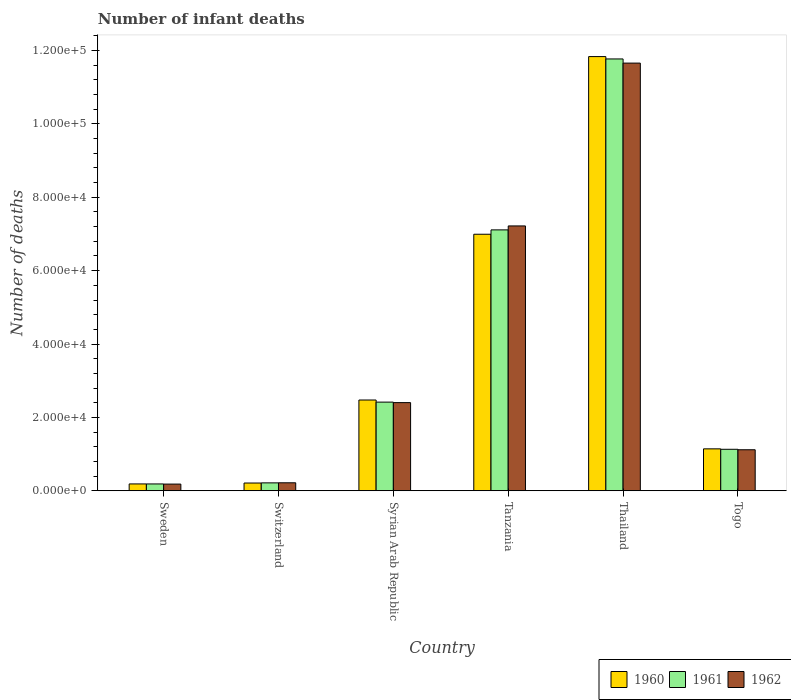Are the number of bars per tick equal to the number of legend labels?
Provide a succinct answer. Yes. Are the number of bars on each tick of the X-axis equal?
Keep it short and to the point. Yes. What is the label of the 4th group of bars from the left?
Make the answer very short. Tanzania. In how many cases, is the number of bars for a given country not equal to the number of legend labels?
Give a very brief answer. 0. What is the number of infant deaths in 1960 in Switzerland?
Offer a very short reply. 2116. Across all countries, what is the maximum number of infant deaths in 1962?
Make the answer very short. 1.17e+05. Across all countries, what is the minimum number of infant deaths in 1962?
Offer a terse response. 1827. In which country was the number of infant deaths in 1960 maximum?
Offer a terse response. Thailand. What is the total number of infant deaths in 1960 in the graph?
Offer a very short reply. 2.28e+05. What is the difference between the number of infant deaths in 1961 in Sweden and that in Tanzania?
Make the answer very short. -6.92e+04. What is the difference between the number of infant deaths in 1962 in Thailand and the number of infant deaths in 1960 in Tanzania?
Offer a terse response. 4.66e+04. What is the average number of infant deaths in 1962 per country?
Your answer should be compact. 3.80e+04. What is the difference between the number of infant deaths of/in 1962 and number of infant deaths of/in 1961 in Switzerland?
Your answer should be very brief. 22. What is the ratio of the number of infant deaths in 1962 in Sweden to that in Togo?
Provide a short and direct response. 0.16. Is the number of infant deaths in 1960 in Switzerland less than that in Thailand?
Provide a succinct answer. Yes. What is the difference between the highest and the second highest number of infant deaths in 1961?
Make the answer very short. -4.66e+04. What is the difference between the highest and the lowest number of infant deaths in 1960?
Provide a succinct answer. 1.16e+05. In how many countries, is the number of infant deaths in 1960 greater than the average number of infant deaths in 1960 taken over all countries?
Offer a very short reply. 2. Is the sum of the number of infant deaths in 1962 in Tanzania and Togo greater than the maximum number of infant deaths in 1960 across all countries?
Make the answer very short. No. Are all the bars in the graph horizontal?
Keep it short and to the point. No. What is the difference between two consecutive major ticks on the Y-axis?
Make the answer very short. 2.00e+04. Does the graph contain grids?
Offer a terse response. No. Where does the legend appear in the graph?
Your answer should be compact. Bottom right. What is the title of the graph?
Provide a succinct answer. Number of infant deaths. Does "1996" appear as one of the legend labels in the graph?
Offer a very short reply. No. What is the label or title of the X-axis?
Your answer should be compact. Country. What is the label or title of the Y-axis?
Ensure brevity in your answer.  Number of deaths. What is the Number of deaths in 1960 in Sweden?
Offer a terse response. 1868. What is the Number of deaths in 1961 in Sweden?
Give a very brief answer. 1865. What is the Number of deaths of 1962 in Sweden?
Offer a very short reply. 1827. What is the Number of deaths of 1960 in Switzerland?
Give a very brief answer. 2116. What is the Number of deaths in 1961 in Switzerland?
Your answer should be compact. 2157. What is the Number of deaths of 1962 in Switzerland?
Your answer should be very brief. 2179. What is the Number of deaths in 1960 in Syrian Arab Republic?
Make the answer very short. 2.47e+04. What is the Number of deaths of 1961 in Syrian Arab Republic?
Keep it short and to the point. 2.42e+04. What is the Number of deaths in 1962 in Syrian Arab Republic?
Make the answer very short. 2.40e+04. What is the Number of deaths of 1960 in Tanzania?
Your answer should be compact. 6.99e+04. What is the Number of deaths in 1961 in Tanzania?
Offer a terse response. 7.11e+04. What is the Number of deaths of 1962 in Tanzania?
Make the answer very short. 7.22e+04. What is the Number of deaths of 1960 in Thailand?
Provide a succinct answer. 1.18e+05. What is the Number of deaths of 1961 in Thailand?
Offer a very short reply. 1.18e+05. What is the Number of deaths in 1962 in Thailand?
Your response must be concise. 1.17e+05. What is the Number of deaths of 1960 in Togo?
Offer a very short reply. 1.14e+04. What is the Number of deaths of 1961 in Togo?
Provide a short and direct response. 1.13e+04. What is the Number of deaths in 1962 in Togo?
Provide a succinct answer. 1.12e+04. Across all countries, what is the maximum Number of deaths in 1960?
Your answer should be compact. 1.18e+05. Across all countries, what is the maximum Number of deaths of 1961?
Your answer should be compact. 1.18e+05. Across all countries, what is the maximum Number of deaths of 1962?
Your response must be concise. 1.17e+05. Across all countries, what is the minimum Number of deaths in 1960?
Keep it short and to the point. 1868. Across all countries, what is the minimum Number of deaths in 1961?
Provide a short and direct response. 1865. Across all countries, what is the minimum Number of deaths of 1962?
Offer a terse response. 1827. What is the total Number of deaths of 1960 in the graph?
Make the answer very short. 2.28e+05. What is the total Number of deaths of 1961 in the graph?
Keep it short and to the point. 2.28e+05. What is the total Number of deaths of 1962 in the graph?
Offer a terse response. 2.28e+05. What is the difference between the Number of deaths in 1960 in Sweden and that in Switzerland?
Give a very brief answer. -248. What is the difference between the Number of deaths in 1961 in Sweden and that in Switzerland?
Provide a succinct answer. -292. What is the difference between the Number of deaths in 1962 in Sweden and that in Switzerland?
Offer a very short reply. -352. What is the difference between the Number of deaths of 1960 in Sweden and that in Syrian Arab Republic?
Provide a short and direct response. -2.29e+04. What is the difference between the Number of deaths of 1961 in Sweden and that in Syrian Arab Republic?
Your response must be concise. -2.23e+04. What is the difference between the Number of deaths of 1962 in Sweden and that in Syrian Arab Republic?
Provide a succinct answer. -2.22e+04. What is the difference between the Number of deaths of 1960 in Sweden and that in Tanzania?
Your response must be concise. -6.81e+04. What is the difference between the Number of deaths in 1961 in Sweden and that in Tanzania?
Offer a very short reply. -6.92e+04. What is the difference between the Number of deaths of 1962 in Sweden and that in Tanzania?
Your answer should be very brief. -7.04e+04. What is the difference between the Number of deaths of 1960 in Sweden and that in Thailand?
Offer a very short reply. -1.16e+05. What is the difference between the Number of deaths in 1961 in Sweden and that in Thailand?
Provide a short and direct response. -1.16e+05. What is the difference between the Number of deaths of 1962 in Sweden and that in Thailand?
Give a very brief answer. -1.15e+05. What is the difference between the Number of deaths in 1960 in Sweden and that in Togo?
Ensure brevity in your answer.  -9563. What is the difference between the Number of deaths of 1961 in Sweden and that in Togo?
Your answer should be very brief. -9446. What is the difference between the Number of deaths in 1962 in Sweden and that in Togo?
Your response must be concise. -9358. What is the difference between the Number of deaths of 1960 in Switzerland and that in Syrian Arab Republic?
Provide a short and direct response. -2.26e+04. What is the difference between the Number of deaths of 1961 in Switzerland and that in Syrian Arab Republic?
Provide a short and direct response. -2.20e+04. What is the difference between the Number of deaths of 1962 in Switzerland and that in Syrian Arab Republic?
Ensure brevity in your answer.  -2.19e+04. What is the difference between the Number of deaths of 1960 in Switzerland and that in Tanzania?
Make the answer very short. -6.78e+04. What is the difference between the Number of deaths of 1961 in Switzerland and that in Tanzania?
Offer a very short reply. -6.90e+04. What is the difference between the Number of deaths of 1962 in Switzerland and that in Tanzania?
Your response must be concise. -7.00e+04. What is the difference between the Number of deaths in 1960 in Switzerland and that in Thailand?
Offer a terse response. -1.16e+05. What is the difference between the Number of deaths in 1961 in Switzerland and that in Thailand?
Keep it short and to the point. -1.16e+05. What is the difference between the Number of deaths of 1962 in Switzerland and that in Thailand?
Offer a very short reply. -1.14e+05. What is the difference between the Number of deaths in 1960 in Switzerland and that in Togo?
Your response must be concise. -9315. What is the difference between the Number of deaths in 1961 in Switzerland and that in Togo?
Your answer should be compact. -9154. What is the difference between the Number of deaths of 1962 in Switzerland and that in Togo?
Provide a succinct answer. -9006. What is the difference between the Number of deaths of 1960 in Syrian Arab Republic and that in Tanzania?
Your answer should be compact. -4.52e+04. What is the difference between the Number of deaths in 1961 in Syrian Arab Republic and that in Tanzania?
Provide a succinct answer. -4.69e+04. What is the difference between the Number of deaths in 1962 in Syrian Arab Republic and that in Tanzania?
Ensure brevity in your answer.  -4.82e+04. What is the difference between the Number of deaths in 1960 in Syrian Arab Republic and that in Thailand?
Make the answer very short. -9.36e+04. What is the difference between the Number of deaths of 1961 in Syrian Arab Republic and that in Thailand?
Provide a succinct answer. -9.35e+04. What is the difference between the Number of deaths in 1962 in Syrian Arab Republic and that in Thailand?
Give a very brief answer. -9.25e+04. What is the difference between the Number of deaths in 1960 in Syrian Arab Republic and that in Togo?
Give a very brief answer. 1.33e+04. What is the difference between the Number of deaths of 1961 in Syrian Arab Republic and that in Togo?
Give a very brief answer. 1.29e+04. What is the difference between the Number of deaths of 1962 in Syrian Arab Republic and that in Togo?
Your answer should be very brief. 1.28e+04. What is the difference between the Number of deaths in 1960 in Tanzania and that in Thailand?
Provide a succinct answer. -4.84e+04. What is the difference between the Number of deaths in 1961 in Tanzania and that in Thailand?
Give a very brief answer. -4.66e+04. What is the difference between the Number of deaths of 1962 in Tanzania and that in Thailand?
Provide a succinct answer. -4.44e+04. What is the difference between the Number of deaths in 1960 in Tanzania and that in Togo?
Offer a very short reply. 5.85e+04. What is the difference between the Number of deaths in 1961 in Tanzania and that in Togo?
Your response must be concise. 5.98e+04. What is the difference between the Number of deaths in 1962 in Tanzania and that in Togo?
Keep it short and to the point. 6.10e+04. What is the difference between the Number of deaths in 1960 in Thailand and that in Togo?
Offer a very short reply. 1.07e+05. What is the difference between the Number of deaths in 1961 in Thailand and that in Togo?
Your response must be concise. 1.06e+05. What is the difference between the Number of deaths of 1962 in Thailand and that in Togo?
Provide a short and direct response. 1.05e+05. What is the difference between the Number of deaths of 1960 in Sweden and the Number of deaths of 1961 in Switzerland?
Provide a succinct answer. -289. What is the difference between the Number of deaths of 1960 in Sweden and the Number of deaths of 1962 in Switzerland?
Ensure brevity in your answer.  -311. What is the difference between the Number of deaths of 1961 in Sweden and the Number of deaths of 1962 in Switzerland?
Keep it short and to the point. -314. What is the difference between the Number of deaths in 1960 in Sweden and the Number of deaths in 1961 in Syrian Arab Republic?
Keep it short and to the point. -2.23e+04. What is the difference between the Number of deaths in 1960 in Sweden and the Number of deaths in 1962 in Syrian Arab Republic?
Offer a terse response. -2.22e+04. What is the difference between the Number of deaths of 1961 in Sweden and the Number of deaths of 1962 in Syrian Arab Republic?
Give a very brief answer. -2.22e+04. What is the difference between the Number of deaths in 1960 in Sweden and the Number of deaths in 1961 in Tanzania?
Keep it short and to the point. -6.92e+04. What is the difference between the Number of deaths in 1960 in Sweden and the Number of deaths in 1962 in Tanzania?
Your answer should be very brief. -7.03e+04. What is the difference between the Number of deaths of 1961 in Sweden and the Number of deaths of 1962 in Tanzania?
Offer a very short reply. -7.03e+04. What is the difference between the Number of deaths of 1960 in Sweden and the Number of deaths of 1961 in Thailand?
Provide a short and direct response. -1.16e+05. What is the difference between the Number of deaths in 1960 in Sweden and the Number of deaths in 1962 in Thailand?
Your answer should be compact. -1.15e+05. What is the difference between the Number of deaths of 1961 in Sweden and the Number of deaths of 1962 in Thailand?
Your answer should be very brief. -1.15e+05. What is the difference between the Number of deaths of 1960 in Sweden and the Number of deaths of 1961 in Togo?
Provide a short and direct response. -9443. What is the difference between the Number of deaths of 1960 in Sweden and the Number of deaths of 1962 in Togo?
Make the answer very short. -9317. What is the difference between the Number of deaths in 1961 in Sweden and the Number of deaths in 1962 in Togo?
Make the answer very short. -9320. What is the difference between the Number of deaths in 1960 in Switzerland and the Number of deaths in 1961 in Syrian Arab Republic?
Keep it short and to the point. -2.21e+04. What is the difference between the Number of deaths in 1960 in Switzerland and the Number of deaths in 1962 in Syrian Arab Republic?
Make the answer very short. -2.19e+04. What is the difference between the Number of deaths in 1961 in Switzerland and the Number of deaths in 1962 in Syrian Arab Republic?
Make the answer very short. -2.19e+04. What is the difference between the Number of deaths in 1960 in Switzerland and the Number of deaths in 1961 in Tanzania?
Offer a terse response. -6.90e+04. What is the difference between the Number of deaths of 1960 in Switzerland and the Number of deaths of 1962 in Tanzania?
Offer a very short reply. -7.01e+04. What is the difference between the Number of deaths of 1961 in Switzerland and the Number of deaths of 1962 in Tanzania?
Make the answer very short. -7.00e+04. What is the difference between the Number of deaths of 1960 in Switzerland and the Number of deaths of 1961 in Thailand?
Keep it short and to the point. -1.16e+05. What is the difference between the Number of deaths in 1960 in Switzerland and the Number of deaths in 1962 in Thailand?
Offer a terse response. -1.14e+05. What is the difference between the Number of deaths in 1961 in Switzerland and the Number of deaths in 1962 in Thailand?
Your answer should be compact. -1.14e+05. What is the difference between the Number of deaths in 1960 in Switzerland and the Number of deaths in 1961 in Togo?
Offer a terse response. -9195. What is the difference between the Number of deaths in 1960 in Switzerland and the Number of deaths in 1962 in Togo?
Keep it short and to the point. -9069. What is the difference between the Number of deaths of 1961 in Switzerland and the Number of deaths of 1962 in Togo?
Keep it short and to the point. -9028. What is the difference between the Number of deaths in 1960 in Syrian Arab Republic and the Number of deaths in 1961 in Tanzania?
Give a very brief answer. -4.64e+04. What is the difference between the Number of deaths in 1960 in Syrian Arab Republic and the Number of deaths in 1962 in Tanzania?
Keep it short and to the point. -4.74e+04. What is the difference between the Number of deaths in 1961 in Syrian Arab Republic and the Number of deaths in 1962 in Tanzania?
Offer a very short reply. -4.80e+04. What is the difference between the Number of deaths in 1960 in Syrian Arab Republic and the Number of deaths in 1961 in Thailand?
Provide a succinct answer. -9.30e+04. What is the difference between the Number of deaths in 1960 in Syrian Arab Republic and the Number of deaths in 1962 in Thailand?
Offer a terse response. -9.18e+04. What is the difference between the Number of deaths of 1961 in Syrian Arab Republic and the Number of deaths of 1962 in Thailand?
Give a very brief answer. -9.24e+04. What is the difference between the Number of deaths in 1960 in Syrian Arab Republic and the Number of deaths in 1961 in Togo?
Provide a succinct answer. 1.34e+04. What is the difference between the Number of deaths of 1960 in Syrian Arab Republic and the Number of deaths of 1962 in Togo?
Offer a terse response. 1.36e+04. What is the difference between the Number of deaths in 1961 in Syrian Arab Republic and the Number of deaths in 1962 in Togo?
Offer a very short reply. 1.30e+04. What is the difference between the Number of deaths in 1960 in Tanzania and the Number of deaths in 1961 in Thailand?
Your answer should be compact. -4.78e+04. What is the difference between the Number of deaths in 1960 in Tanzania and the Number of deaths in 1962 in Thailand?
Keep it short and to the point. -4.66e+04. What is the difference between the Number of deaths in 1961 in Tanzania and the Number of deaths in 1962 in Thailand?
Give a very brief answer. -4.55e+04. What is the difference between the Number of deaths in 1960 in Tanzania and the Number of deaths in 1961 in Togo?
Offer a very short reply. 5.86e+04. What is the difference between the Number of deaths in 1960 in Tanzania and the Number of deaths in 1962 in Togo?
Keep it short and to the point. 5.87e+04. What is the difference between the Number of deaths of 1961 in Tanzania and the Number of deaths of 1962 in Togo?
Make the answer very short. 5.99e+04. What is the difference between the Number of deaths in 1960 in Thailand and the Number of deaths in 1961 in Togo?
Offer a terse response. 1.07e+05. What is the difference between the Number of deaths in 1960 in Thailand and the Number of deaths in 1962 in Togo?
Ensure brevity in your answer.  1.07e+05. What is the difference between the Number of deaths in 1961 in Thailand and the Number of deaths in 1962 in Togo?
Provide a short and direct response. 1.07e+05. What is the average Number of deaths in 1960 per country?
Ensure brevity in your answer.  3.81e+04. What is the average Number of deaths in 1961 per country?
Ensure brevity in your answer.  3.81e+04. What is the average Number of deaths in 1962 per country?
Keep it short and to the point. 3.80e+04. What is the difference between the Number of deaths in 1960 and Number of deaths in 1961 in Sweden?
Keep it short and to the point. 3. What is the difference between the Number of deaths of 1960 and Number of deaths of 1962 in Sweden?
Provide a short and direct response. 41. What is the difference between the Number of deaths of 1960 and Number of deaths of 1961 in Switzerland?
Your answer should be very brief. -41. What is the difference between the Number of deaths of 1960 and Number of deaths of 1962 in Switzerland?
Offer a very short reply. -63. What is the difference between the Number of deaths in 1961 and Number of deaths in 1962 in Switzerland?
Your answer should be compact. -22. What is the difference between the Number of deaths of 1960 and Number of deaths of 1961 in Syrian Arab Republic?
Offer a terse response. 572. What is the difference between the Number of deaths in 1960 and Number of deaths in 1962 in Syrian Arab Republic?
Make the answer very short. 711. What is the difference between the Number of deaths in 1961 and Number of deaths in 1962 in Syrian Arab Republic?
Your answer should be compact. 139. What is the difference between the Number of deaths in 1960 and Number of deaths in 1961 in Tanzania?
Your answer should be compact. -1186. What is the difference between the Number of deaths in 1960 and Number of deaths in 1962 in Tanzania?
Keep it short and to the point. -2266. What is the difference between the Number of deaths of 1961 and Number of deaths of 1962 in Tanzania?
Your response must be concise. -1080. What is the difference between the Number of deaths of 1960 and Number of deaths of 1961 in Thailand?
Your answer should be compact. 643. What is the difference between the Number of deaths in 1960 and Number of deaths in 1962 in Thailand?
Your response must be concise. 1775. What is the difference between the Number of deaths of 1961 and Number of deaths of 1962 in Thailand?
Keep it short and to the point. 1132. What is the difference between the Number of deaths in 1960 and Number of deaths in 1961 in Togo?
Your answer should be compact. 120. What is the difference between the Number of deaths in 1960 and Number of deaths in 1962 in Togo?
Provide a short and direct response. 246. What is the difference between the Number of deaths in 1961 and Number of deaths in 1962 in Togo?
Your answer should be compact. 126. What is the ratio of the Number of deaths of 1960 in Sweden to that in Switzerland?
Give a very brief answer. 0.88. What is the ratio of the Number of deaths of 1961 in Sweden to that in Switzerland?
Give a very brief answer. 0.86. What is the ratio of the Number of deaths of 1962 in Sweden to that in Switzerland?
Ensure brevity in your answer.  0.84. What is the ratio of the Number of deaths in 1960 in Sweden to that in Syrian Arab Republic?
Provide a succinct answer. 0.08. What is the ratio of the Number of deaths of 1961 in Sweden to that in Syrian Arab Republic?
Provide a short and direct response. 0.08. What is the ratio of the Number of deaths of 1962 in Sweden to that in Syrian Arab Republic?
Provide a succinct answer. 0.08. What is the ratio of the Number of deaths in 1960 in Sweden to that in Tanzania?
Make the answer very short. 0.03. What is the ratio of the Number of deaths of 1961 in Sweden to that in Tanzania?
Offer a terse response. 0.03. What is the ratio of the Number of deaths in 1962 in Sweden to that in Tanzania?
Provide a short and direct response. 0.03. What is the ratio of the Number of deaths of 1960 in Sweden to that in Thailand?
Give a very brief answer. 0.02. What is the ratio of the Number of deaths of 1961 in Sweden to that in Thailand?
Your response must be concise. 0.02. What is the ratio of the Number of deaths in 1962 in Sweden to that in Thailand?
Your response must be concise. 0.02. What is the ratio of the Number of deaths in 1960 in Sweden to that in Togo?
Keep it short and to the point. 0.16. What is the ratio of the Number of deaths in 1961 in Sweden to that in Togo?
Ensure brevity in your answer.  0.16. What is the ratio of the Number of deaths in 1962 in Sweden to that in Togo?
Your answer should be compact. 0.16. What is the ratio of the Number of deaths of 1960 in Switzerland to that in Syrian Arab Republic?
Make the answer very short. 0.09. What is the ratio of the Number of deaths of 1961 in Switzerland to that in Syrian Arab Republic?
Your response must be concise. 0.09. What is the ratio of the Number of deaths in 1962 in Switzerland to that in Syrian Arab Republic?
Your answer should be compact. 0.09. What is the ratio of the Number of deaths of 1960 in Switzerland to that in Tanzania?
Provide a short and direct response. 0.03. What is the ratio of the Number of deaths in 1961 in Switzerland to that in Tanzania?
Offer a very short reply. 0.03. What is the ratio of the Number of deaths of 1962 in Switzerland to that in Tanzania?
Provide a succinct answer. 0.03. What is the ratio of the Number of deaths in 1960 in Switzerland to that in Thailand?
Keep it short and to the point. 0.02. What is the ratio of the Number of deaths of 1961 in Switzerland to that in Thailand?
Provide a short and direct response. 0.02. What is the ratio of the Number of deaths in 1962 in Switzerland to that in Thailand?
Your answer should be compact. 0.02. What is the ratio of the Number of deaths of 1960 in Switzerland to that in Togo?
Make the answer very short. 0.19. What is the ratio of the Number of deaths of 1961 in Switzerland to that in Togo?
Keep it short and to the point. 0.19. What is the ratio of the Number of deaths of 1962 in Switzerland to that in Togo?
Provide a succinct answer. 0.19. What is the ratio of the Number of deaths in 1960 in Syrian Arab Republic to that in Tanzania?
Your response must be concise. 0.35. What is the ratio of the Number of deaths in 1961 in Syrian Arab Republic to that in Tanzania?
Make the answer very short. 0.34. What is the ratio of the Number of deaths in 1962 in Syrian Arab Republic to that in Tanzania?
Your answer should be very brief. 0.33. What is the ratio of the Number of deaths in 1960 in Syrian Arab Republic to that in Thailand?
Offer a terse response. 0.21. What is the ratio of the Number of deaths in 1961 in Syrian Arab Republic to that in Thailand?
Provide a succinct answer. 0.21. What is the ratio of the Number of deaths of 1962 in Syrian Arab Republic to that in Thailand?
Keep it short and to the point. 0.21. What is the ratio of the Number of deaths of 1960 in Syrian Arab Republic to that in Togo?
Provide a succinct answer. 2.16. What is the ratio of the Number of deaths in 1961 in Syrian Arab Republic to that in Togo?
Provide a succinct answer. 2.14. What is the ratio of the Number of deaths of 1962 in Syrian Arab Republic to that in Togo?
Provide a succinct answer. 2.15. What is the ratio of the Number of deaths of 1960 in Tanzania to that in Thailand?
Ensure brevity in your answer.  0.59. What is the ratio of the Number of deaths of 1961 in Tanzania to that in Thailand?
Provide a succinct answer. 0.6. What is the ratio of the Number of deaths in 1962 in Tanzania to that in Thailand?
Give a very brief answer. 0.62. What is the ratio of the Number of deaths in 1960 in Tanzania to that in Togo?
Your response must be concise. 6.12. What is the ratio of the Number of deaths of 1961 in Tanzania to that in Togo?
Your response must be concise. 6.29. What is the ratio of the Number of deaths of 1962 in Tanzania to that in Togo?
Ensure brevity in your answer.  6.45. What is the ratio of the Number of deaths of 1960 in Thailand to that in Togo?
Provide a succinct answer. 10.35. What is the ratio of the Number of deaths of 1961 in Thailand to that in Togo?
Give a very brief answer. 10.41. What is the ratio of the Number of deaths of 1962 in Thailand to that in Togo?
Make the answer very short. 10.42. What is the difference between the highest and the second highest Number of deaths in 1960?
Your answer should be very brief. 4.84e+04. What is the difference between the highest and the second highest Number of deaths in 1961?
Your answer should be compact. 4.66e+04. What is the difference between the highest and the second highest Number of deaths of 1962?
Offer a very short reply. 4.44e+04. What is the difference between the highest and the lowest Number of deaths in 1960?
Your answer should be compact. 1.16e+05. What is the difference between the highest and the lowest Number of deaths of 1961?
Provide a short and direct response. 1.16e+05. What is the difference between the highest and the lowest Number of deaths in 1962?
Make the answer very short. 1.15e+05. 